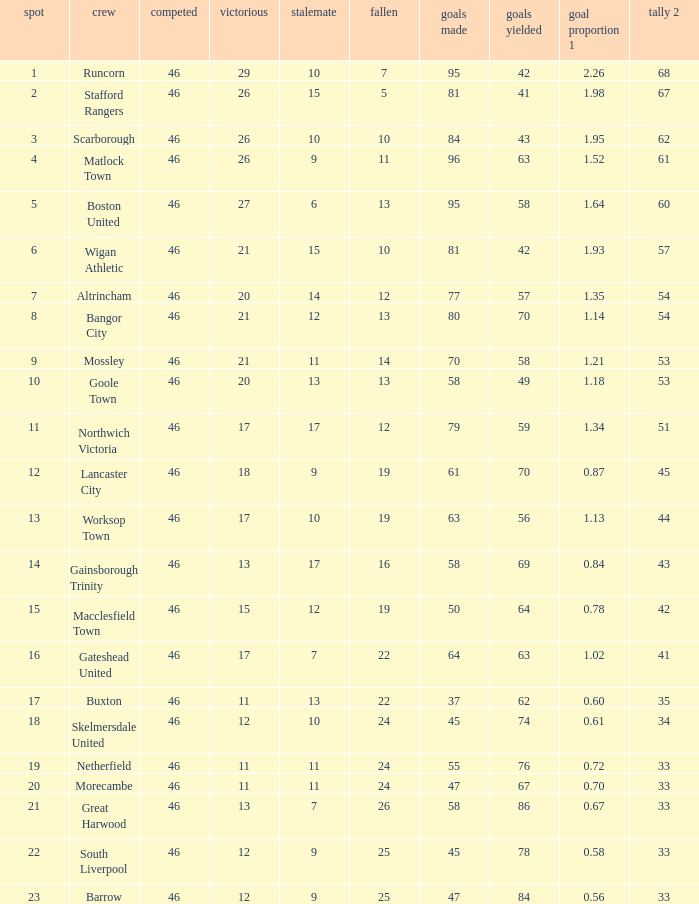What is the highest position of the Bangor City team? 8.0. 